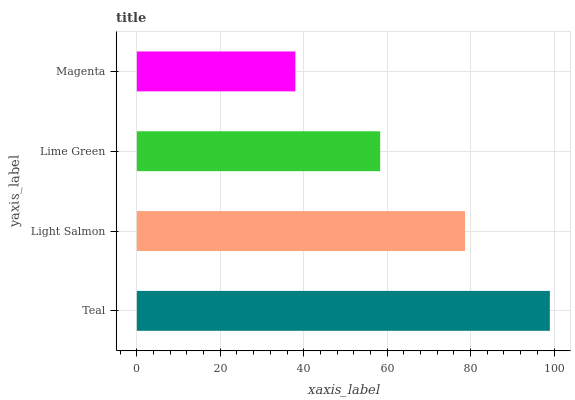Is Magenta the minimum?
Answer yes or no. Yes. Is Teal the maximum?
Answer yes or no. Yes. Is Light Salmon the minimum?
Answer yes or no. No. Is Light Salmon the maximum?
Answer yes or no. No. Is Teal greater than Light Salmon?
Answer yes or no. Yes. Is Light Salmon less than Teal?
Answer yes or no. Yes. Is Light Salmon greater than Teal?
Answer yes or no. No. Is Teal less than Light Salmon?
Answer yes or no. No. Is Light Salmon the high median?
Answer yes or no. Yes. Is Lime Green the low median?
Answer yes or no. Yes. Is Lime Green the high median?
Answer yes or no. No. Is Magenta the low median?
Answer yes or no. No. 